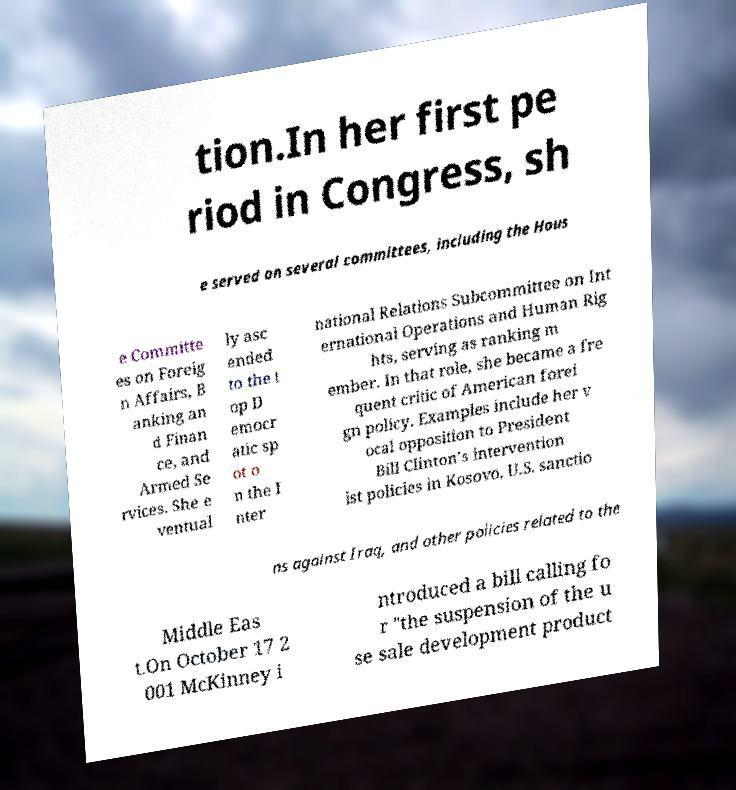Could you assist in decoding the text presented in this image and type it out clearly? tion.In her first pe riod in Congress, sh e served on several committees, including the Hous e Committe es on Foreig n Affairs, B anking an d Finan ce, and Armed Se rvices. She e ventual ly asc ended to the t op D emocr atic sp ot o n the I nter national Relations Subcommittee on Int ernational Operations and Human Rig hts, serving as ranking m ember. In that role, she became a fre quent critic of American forei gn policy. Examples include her v ocal opposition to President Bill Clinton’s intervention ist policies in Kosovo, U.S. sanctio ns against Iraq, and other policies related to the Middle Eas t.On October 17 2 001 McKinney i ntroduced a bill calling fo r "the suspension of the u se sale development product 